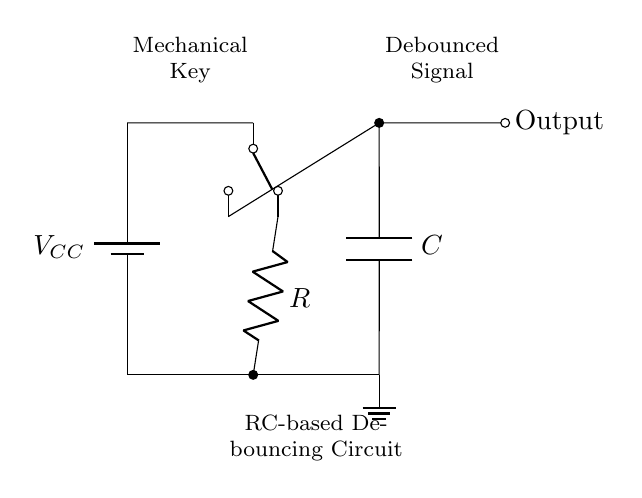What is the power source used in this circuit? The power source is denoted by the battery symbol labeled with VCC, indicating the voltage supply for the circuit.
Answer: VCC What component is responsible for smoothing out the mechanical key presses? The capacitor, labeled C in the circuit, works to filter out rapid changes in voltage, thus smoothing the signal received from the mechanical key.
Answer: C What type of circuit is represented here? This is an RC-based debouncing circuit, which combines a resistor and a capacitor to stabilize the signal from the switch.
Answer: RC-based debouncing circuit How many resistors are present in the diagram? The circuit contains one resistor, labeled R, which is connected in series with the switch.
Answer: 1 What does the output from the circuit represent? The output, marked as Output in the diagram, signifies the debounced signal that has been processed to eliminate noise and fluctuations caused by mechanical switching.
Answer: Debounced Signal What happens when the mechanical key is pressed? Pressing the mechanical key closes the switch, which allows current to flow through the resistor and charges the capacitor, generating a stable output signal.
Answer: Current flows What is the role of the resistor in this circuit? The resistor helps limit the current flowing into the capacitor, controlling the charge and discharge time, which affects the time constant of the circuit and determines the debounce duration.
Answer: Limit current 